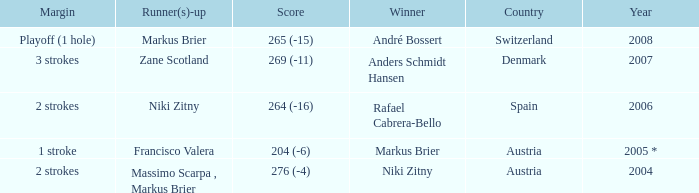Who was the runner-up when the margin was 1 stroke? Francisco Valera. 